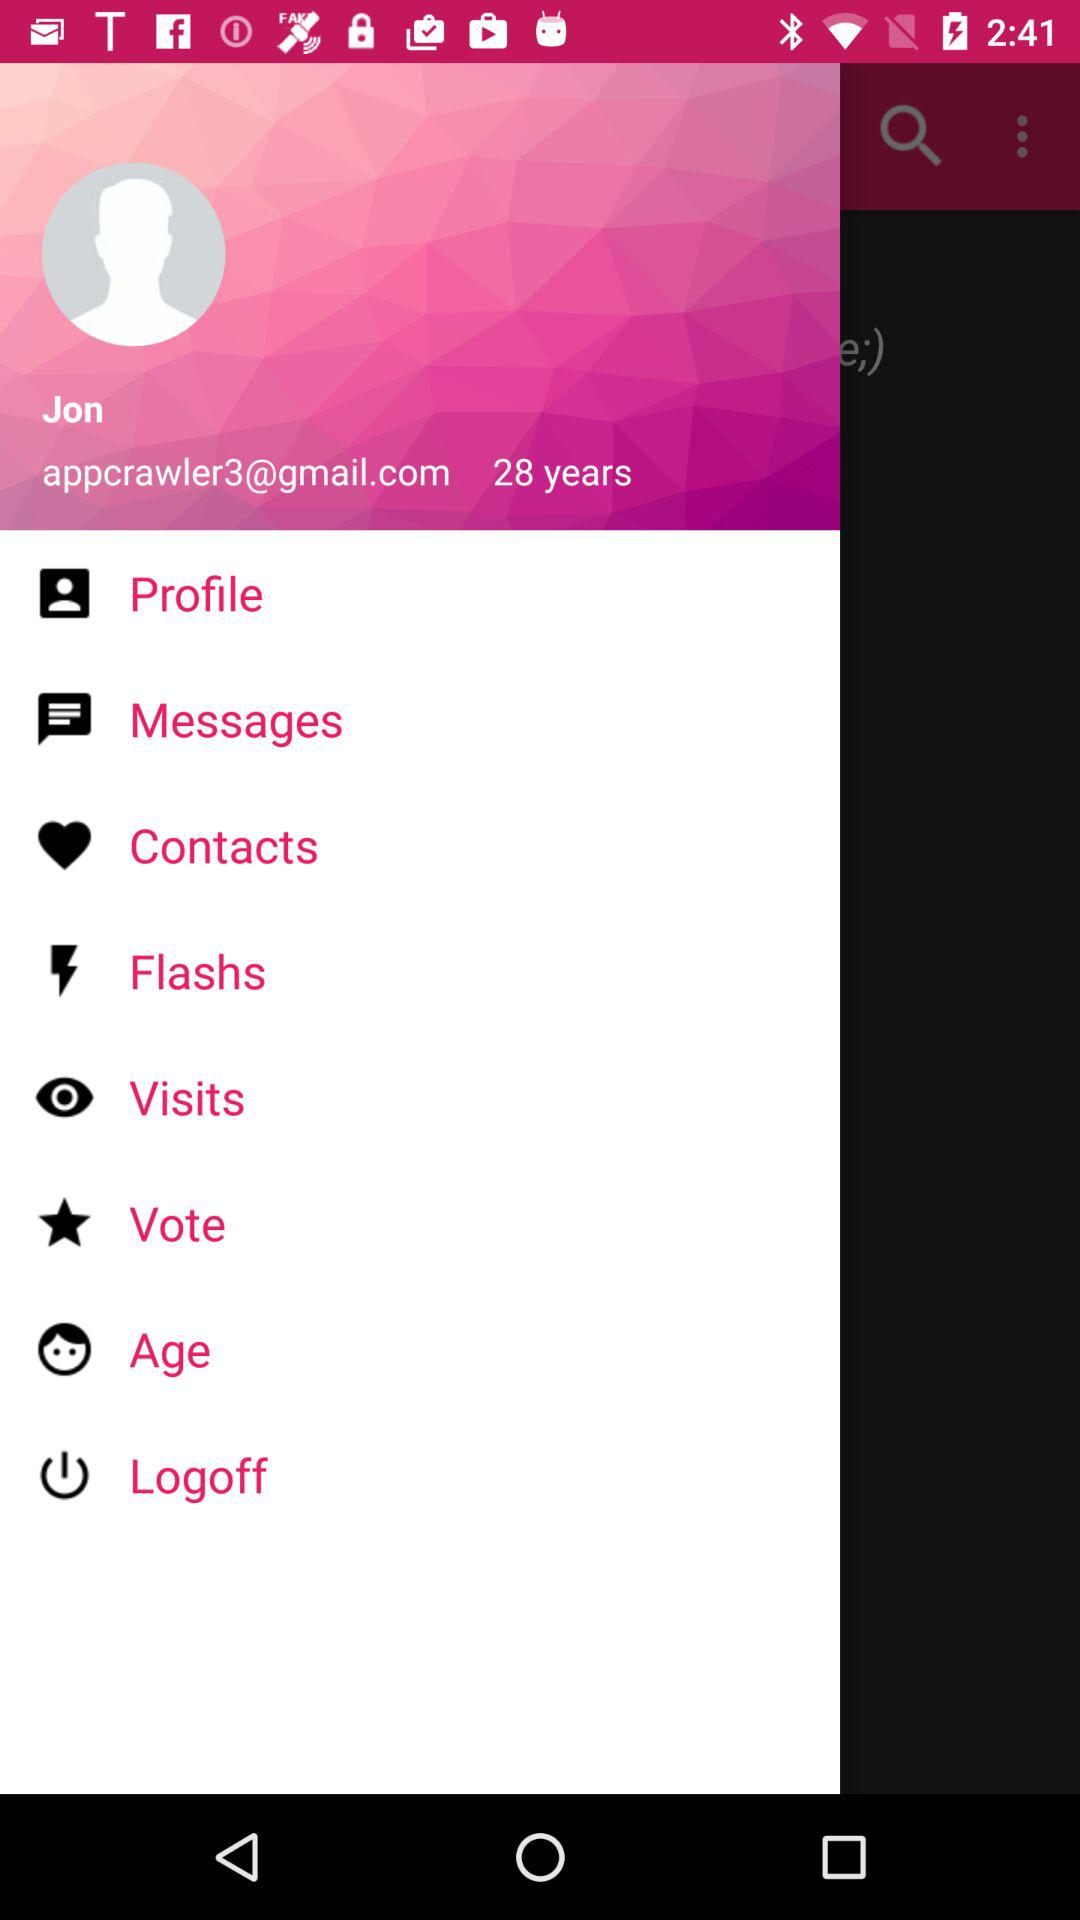What is the given email address? The given email address is appcrawler3@gmail.com. 